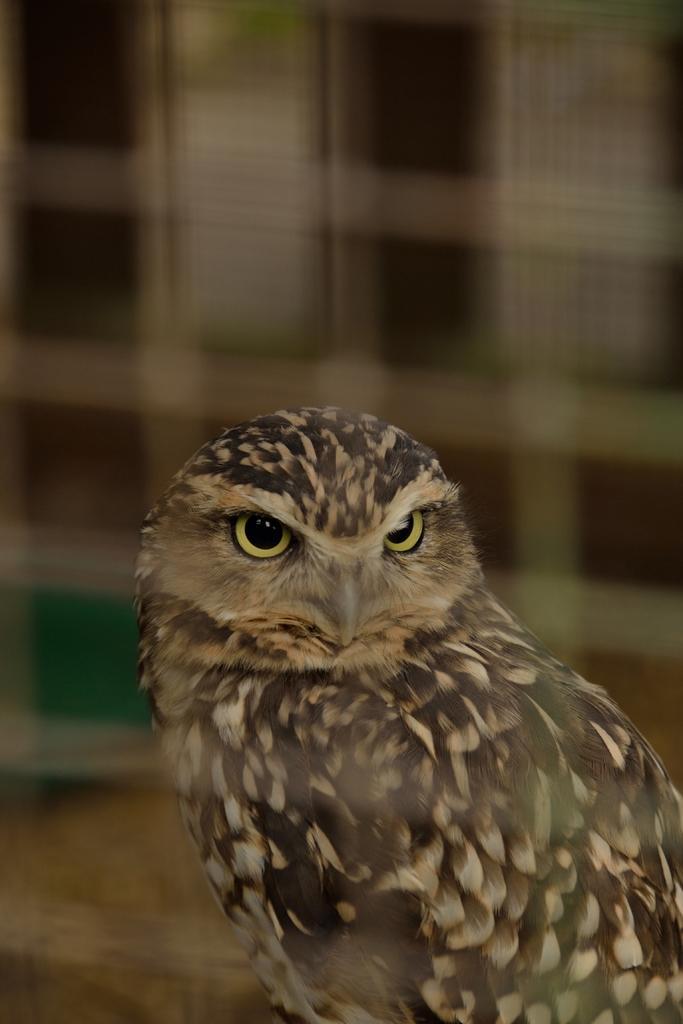How would you summarize this image in a sentence or two? In the picture I can see a bird called owl. 